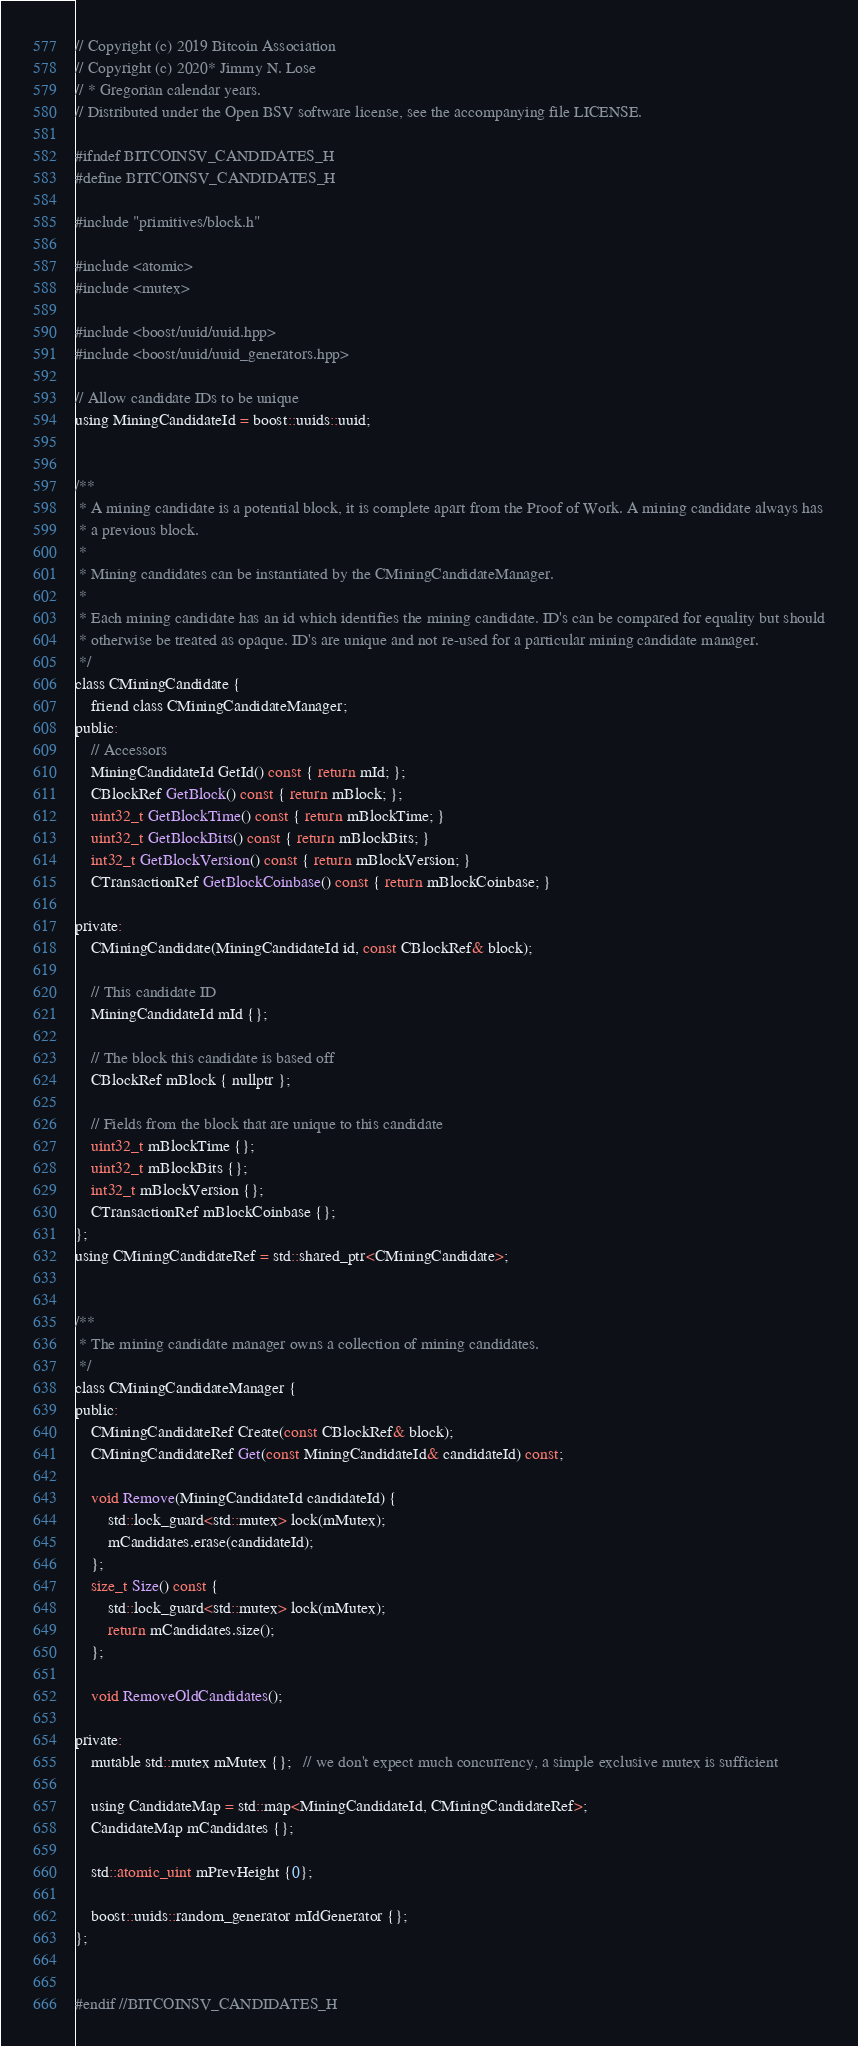Convert code to text. <code><loc_0><loc_0><loc_500><loc_500><_C_>// Copyright (c) 2019 Bitcoin Association
// Copyright (c) 2020* Jimmy N. Lose
// * Gregorian calendar years.
// Distributed under the Open BSV software license, see the accompanying file LICENSE.

#ifndef BITCOINSV_CANDIDATES_H
#define BITCOINSV_CANDIDATES_H

#include "primitives/block.h"

#include <atomic>
#include <mutex>

#include <boost/uuid/uuid.hpp>
#include <boost/uuid/uuid_generators.hpp>

// Allow candidate IDs to be unique
using MiningCandidateId = boost::uuids::uuid;


/**
 * A mining candidate is a potential block, it is complete apart from the Proof of Work. A mining candidate always has
 * a previous block.
 *
 * Mining candidates can be instantiated by the CMiningCandidateManager.
 *
 * Each mining candidate has an id which identifies the mining candidate. ID's can be compared for equality but should
 * otherwise be treated as opaque. ID's are unique and not re-used for a particular mining candidate manager.
 */
class CMiningCandidate {
    friend class CMiningCandidateManager;
public:
    // Accessors
    MiningCandidateId GetId() const { return mId; };
    CBlockRef GetBlock() const { return mBlock; };
    uint32_t GetBlockTime() const { return mBlockTime; }
    uint32_t GetBlockBits() const { return mBlockBits; }
    int32_t GetBlockVersion() const { return mBlockVersion; }
    CTransactionRef GetBlockCoinbase() const { return mBlockCoinbase; }

private:
    CMiningCandidate(MiningCandidateId id, const CBlockRef& block);

    // This candidate ID
    MiningCandidateId mId {};

    // The block this candidate is based off
    CBlockRef mBlock { nullptr };

    // Fields from the block that are unique to this candidate
    uint32_t mBlockTime {};
    uint32_t mBlockBits {};
    int32_t mBlockVersion {};
    CTransactionRef mBlockCoinbase {};
};
using CMiningCandidateRef = std::shared_ptr<CMiningCandidate>;


/**
 * The mining candidate manager owns a collection of mining candidates.
 */
class CMiningCandidateManager {
public:
    CMiningCandidateRef Create(const CBlockRef& block);
    CMiningCandidateRef Get(const MiningCandidateId& candidateId) const;

    void Remove(MiningCandidateId candidateId) {
        std::lock_guard<std::mutex> lock(mMutex);
        mCandidates.erase(candidateId);
    };
    size_t Size() const {
        std::lock_guard<std::mutex> lock(mMutex);
        return mCandidates.size();
    };

    void RemoveOldCandidates();

private:
    mutable std::mutex mMutex {};   // we don't expect much concurrency, a simple exclusive mutex is sufficient

    using CandidateMap = std::map<MiningCandidateId, CMiningCandidateRef>;
    CandidateMap mCandidates {};

    std::atomic_uint mPrevHeight {0};

    boost::uuids::random_generator mIdGenerator {};
};


#endif //BITCOINSV_CANDIDATES_H
</code> 